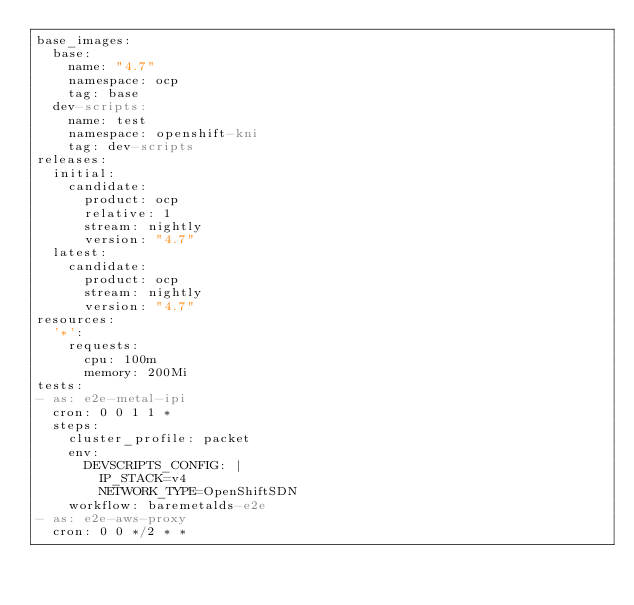<code> <loc_0><loc_0><loc_500><loc_500><_YAML_>base_images:
  base:
    name: "4.7"
    namespace: ocp
    tag: base
  dev-scripts:
    name: test
    namespace: openshift-kni
    tag: dev-scripts
releases:
  initial:
    candidate:
      product: ocp
      relative: 1
      stream: nightly
      version: "4.7"
  latest:
    candidate:
      product: ocp
      stream: nightly
      version: "4.7"
resources:
  '*':
    requests:
      cpu: 100m
      memory: 200Mi
tests:
- as: e2e-metal-ipi
  cron: 0 0 1 1 *
  steps:
    cluster_profile: packet
    env:
      DEVSCRIPTS_CONFIG: |
        IP_STACK=v4
        NETWORK_TYPE=OpenShiftSDN
    workflow: baremetalds-e2e
- as: e2e-aws-proxy
  cron: 0 0 */2 * *</code> 